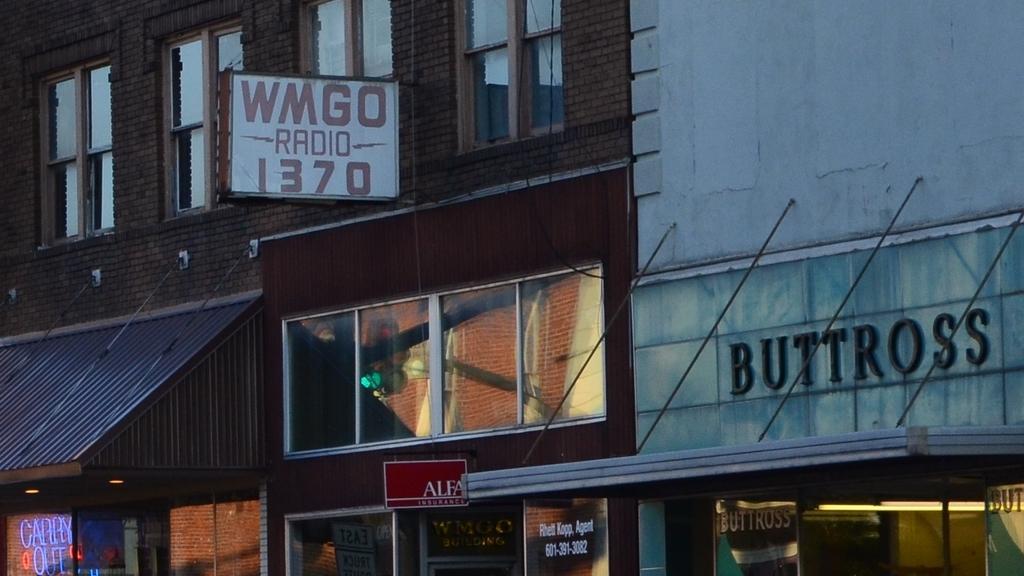Please provide a concise description of this image. In this image we can see buildings, windows, name board on the wall, text written on the wall, glass doors, lights, boards and other objects. 